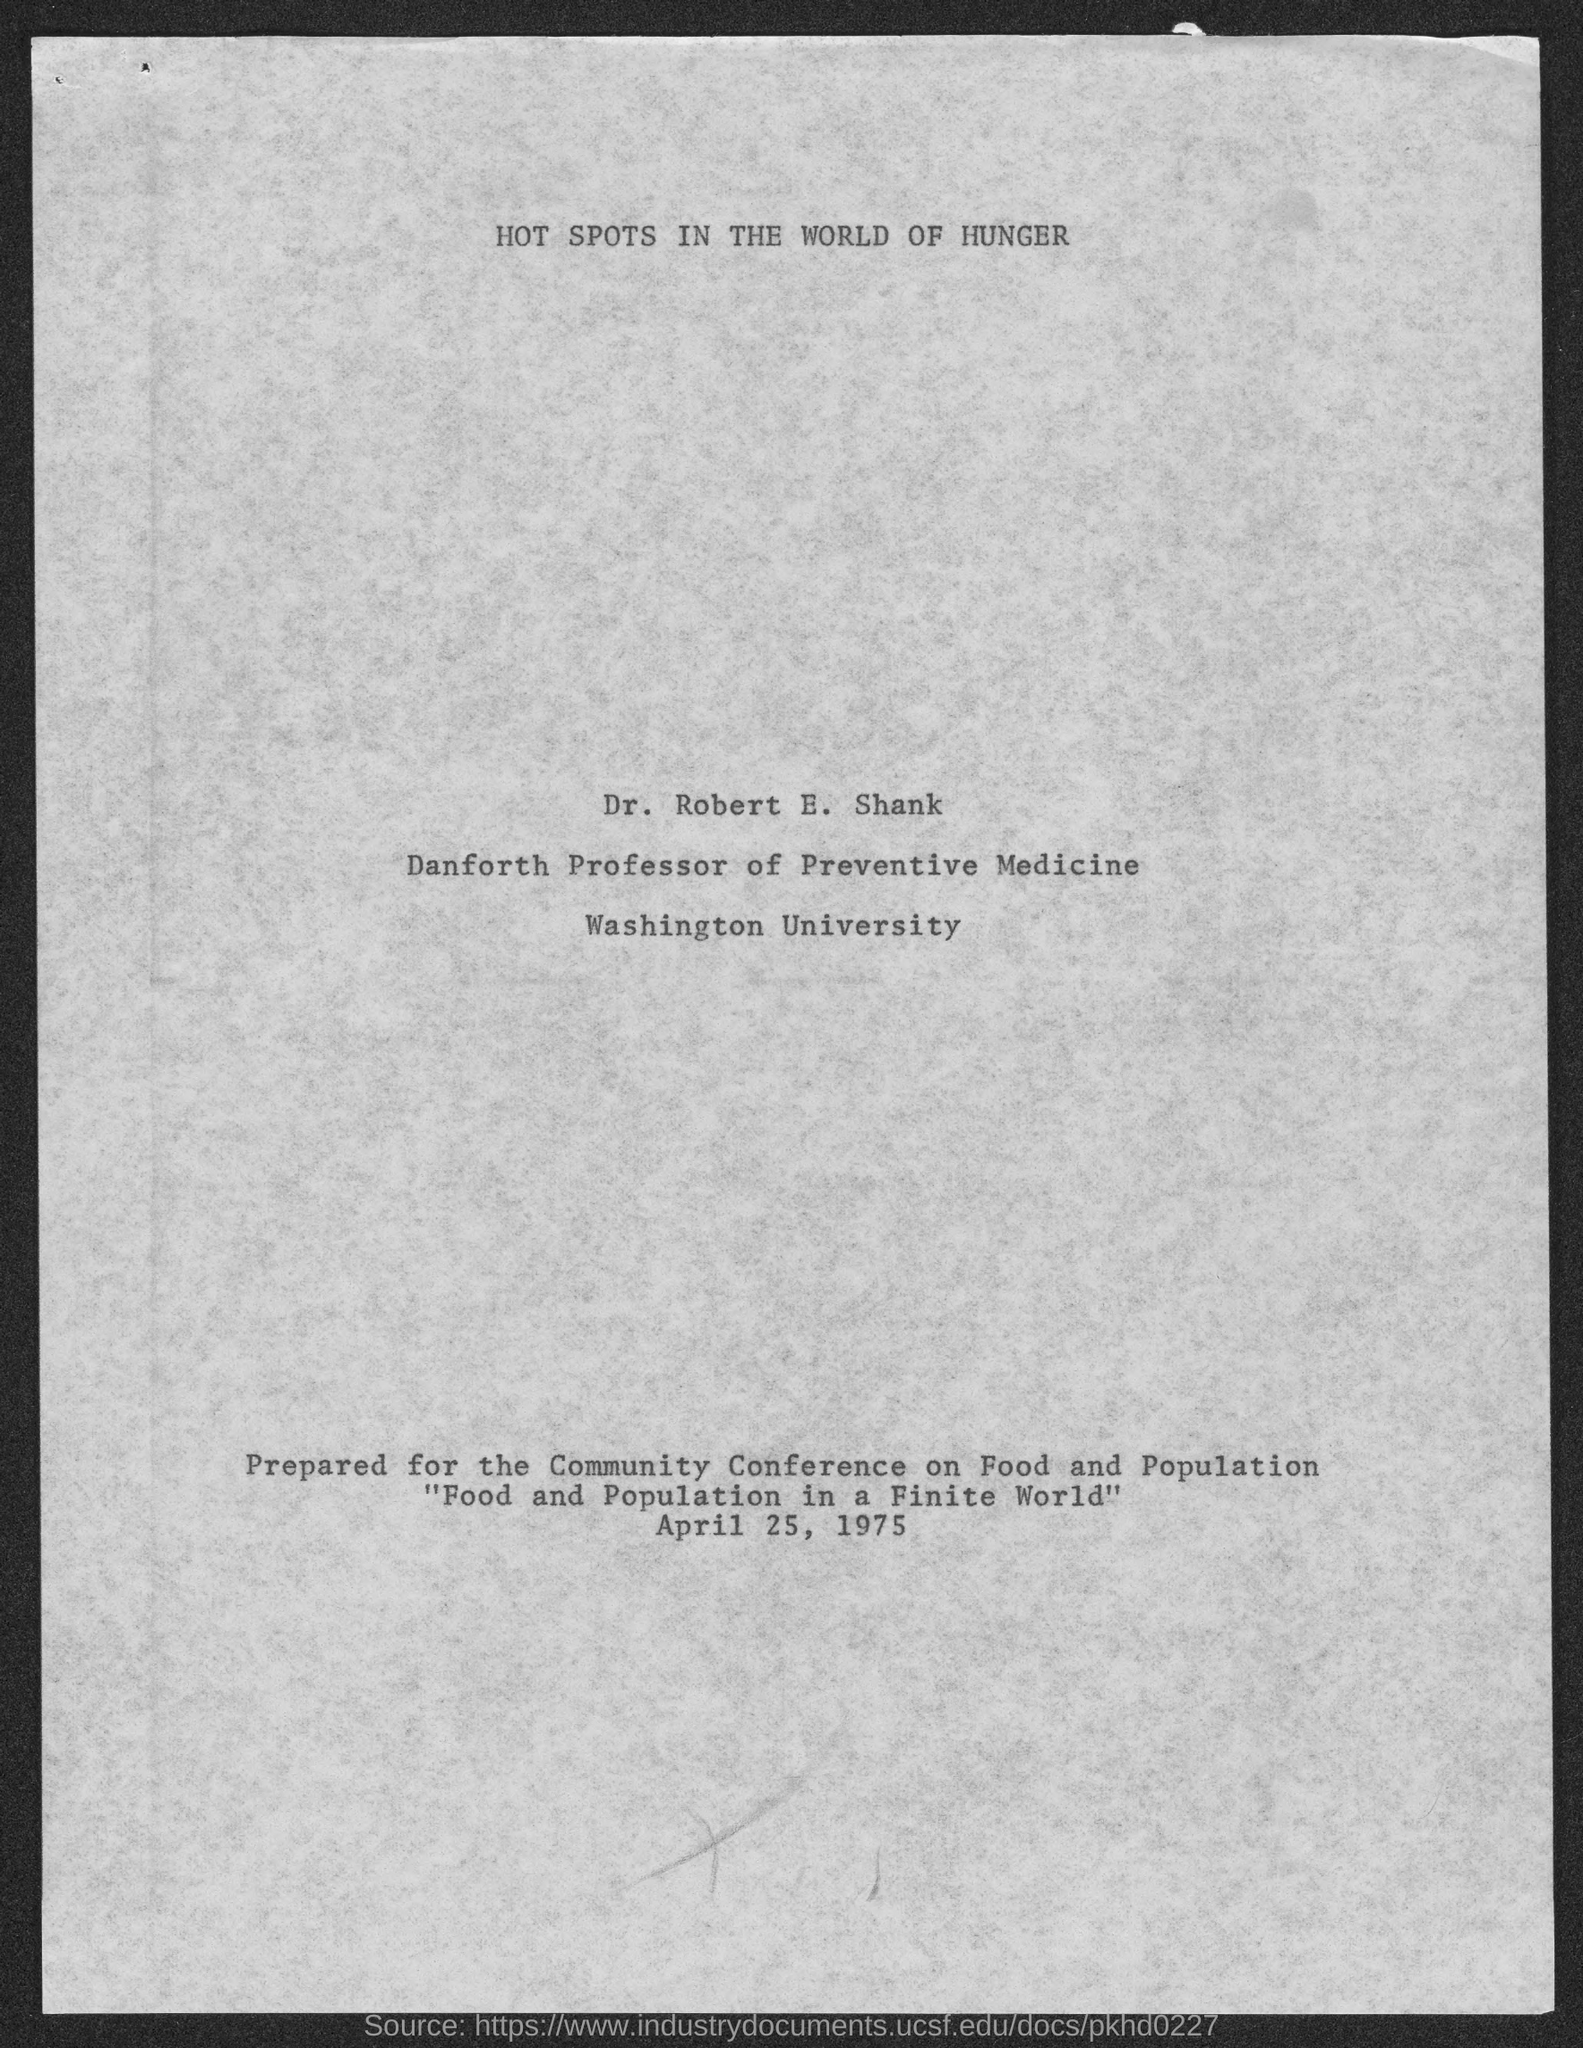What is the position of dr. robert e. shank ?
Ensure brevity in your answer.  Danforth Professor of Preventive Medicine. To which university does Dr. Robert E. Shank belong ?
Your response must be concise. Washington University. 